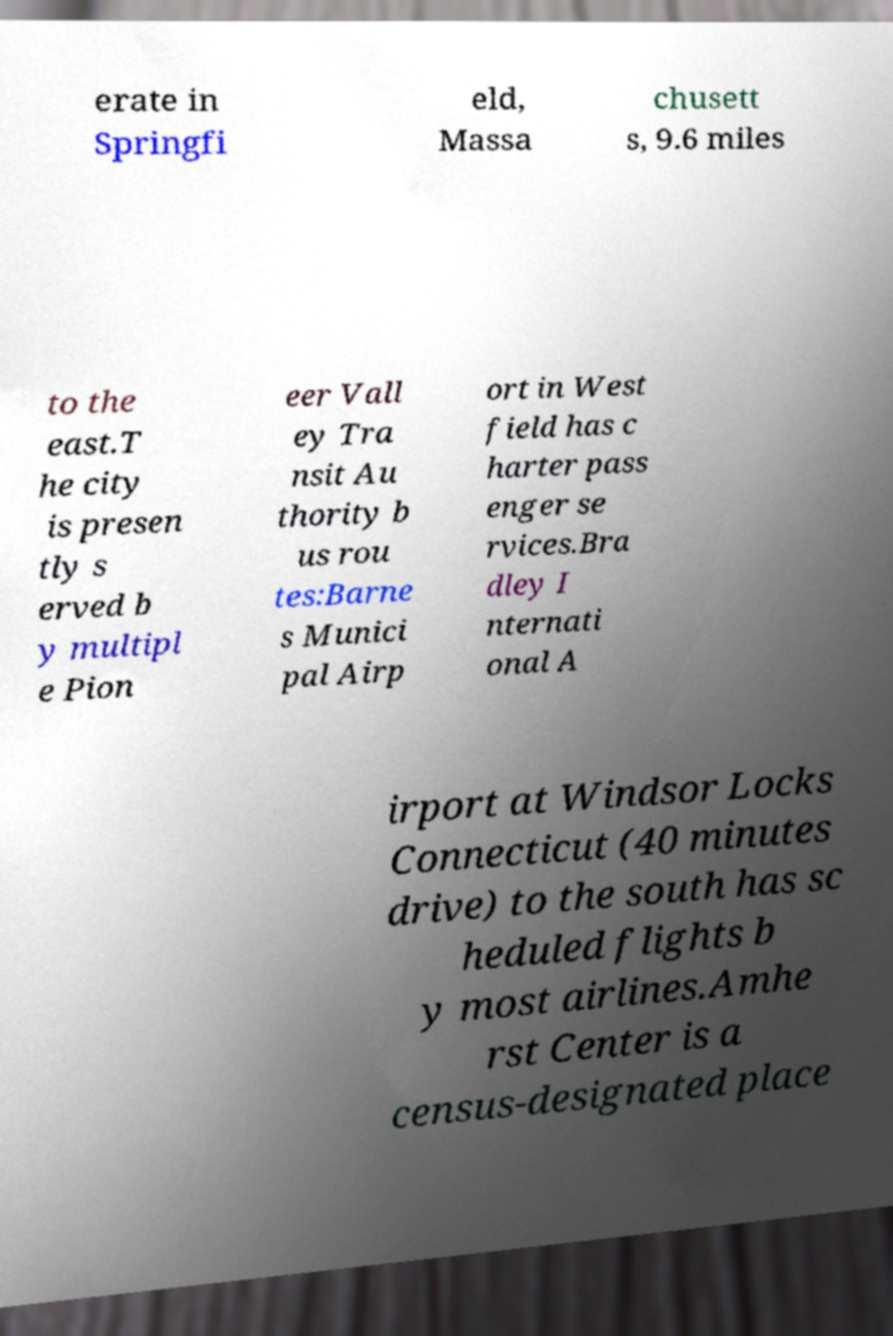For documentation purposes, I need the text within this image transcribed. Could you provide that? erate in Springfi eld, Massa chusett s, 9.6 miles to the east.T he city is presen tly s erved b y multipl e Pion eer Vall ey Tra nsit Au thority b us rou tes:Barne s Munici pal Airp ort in West field has c harter pass enger se rvices.Bra dley I nternati onal A irport at Windsor Locks Connecticut (40 minutes drive) to the south has sc heduled flights b y most airlines.Amhe rst Center is a census-designated place 